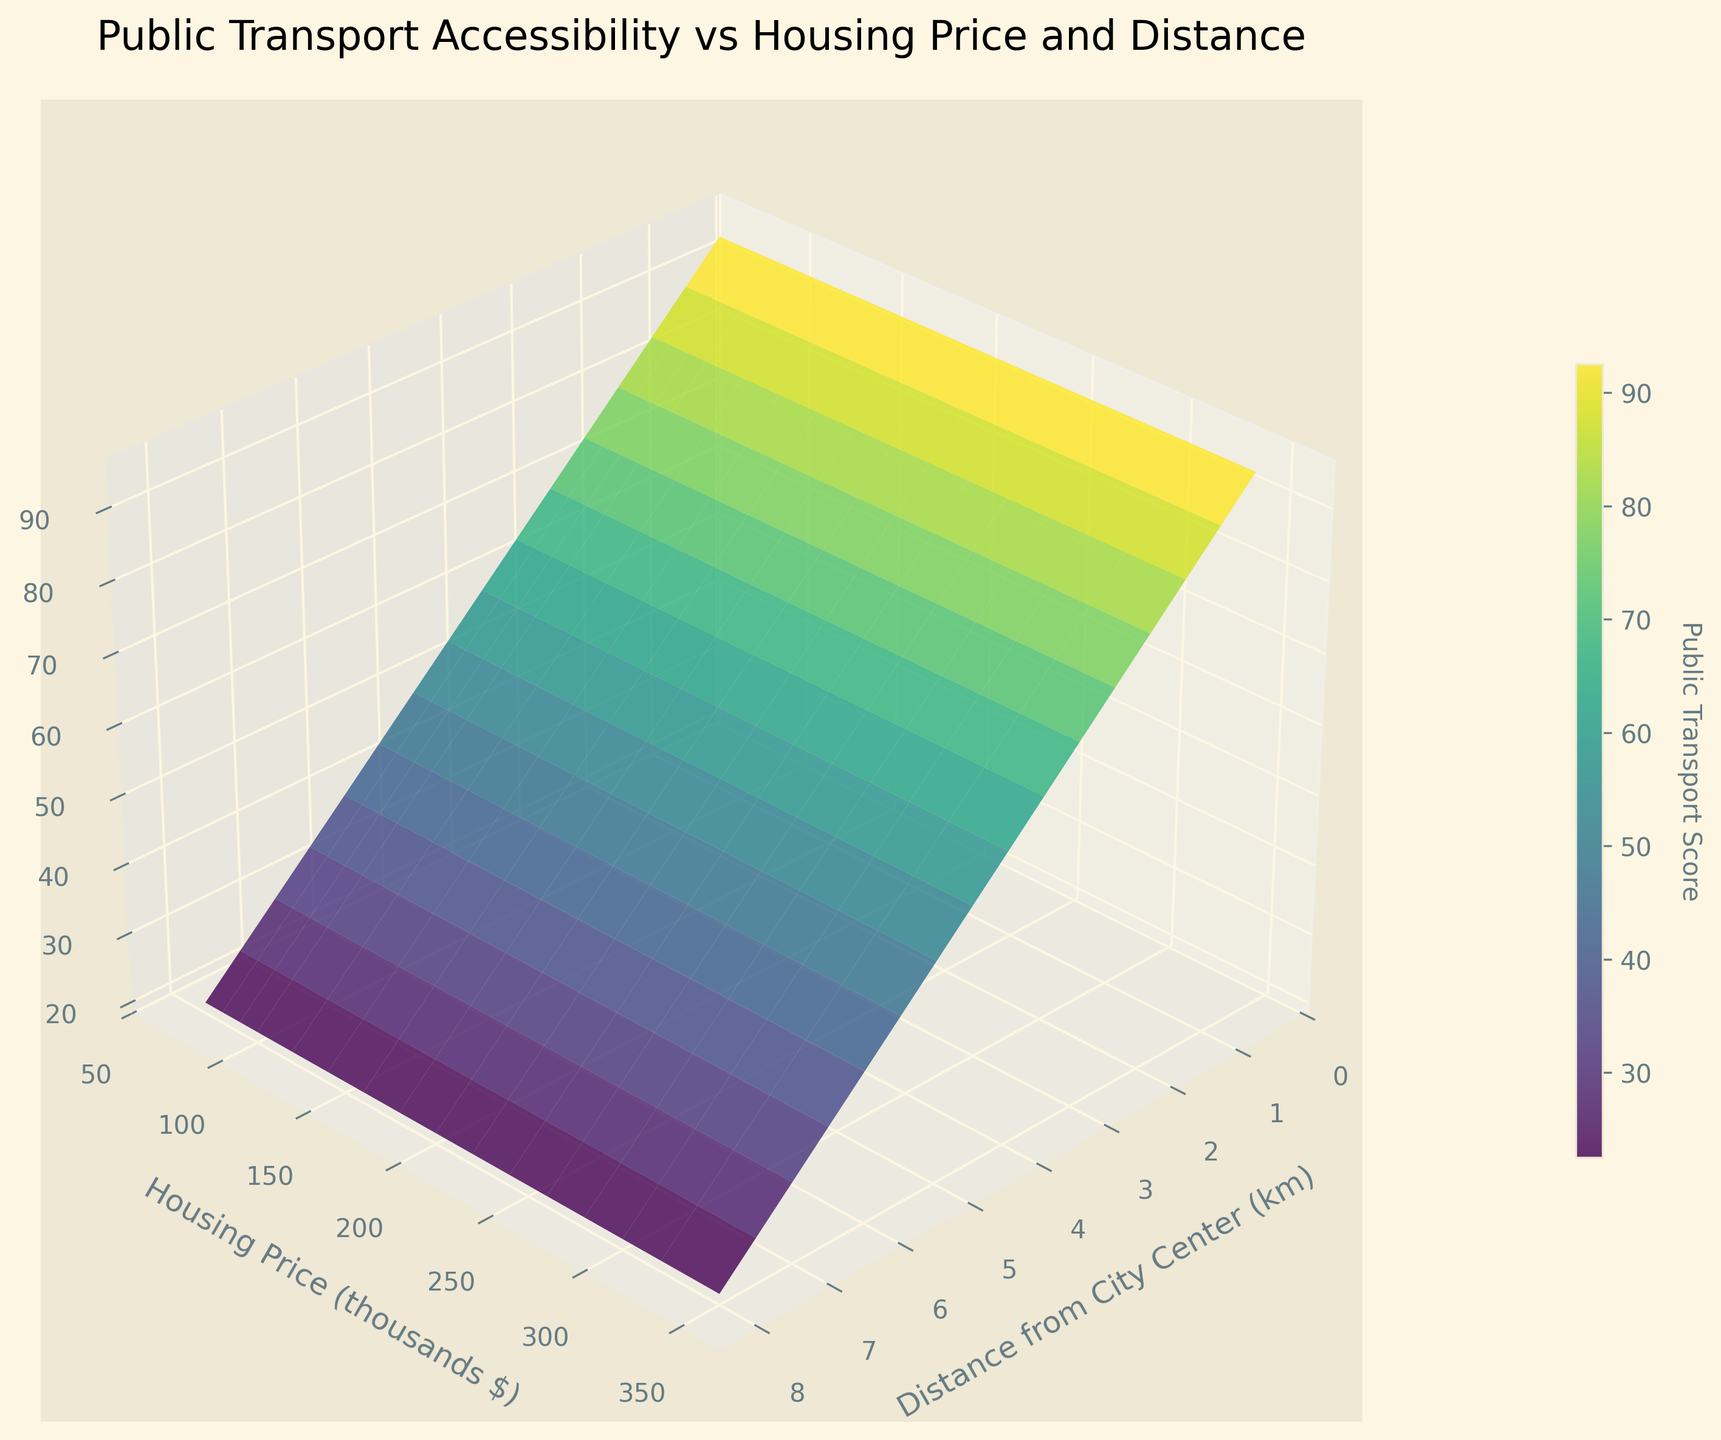What's the title of the plot? The title is usually located at the top of the plot, providing a brief description of what the plot represents.
Answer: Public Transport Accessibility vs Housing Price and Distance What does the color bar represent? The color bar is typically used to illustrate the range of values for a certain variable in the plot, as indicated by its label. Here, it indicates the range of Public Transport Scores.
Answer: Public Transport Score How does the Public Transport Score change with the distance from the city center? Observing the z-axis (Public Transport Score) as the x-axis (Distance from City Center) increases, the score consistently decreases, showing an inverse relationship.
Answer: It decreases At what distance from the city center does the Public Transport Score drop below 50? Refer to the point on the x-axis where the z-axis value (Public Transport Score) becomes less than 50.
Answer: 5 km Which housing price range has the highest Public Transport Score? By analyzing the y-axis (Housing Price) in conjunction with the color indicating Public Transport Score, the highest scores are seen at the lower end of the distance range.
Answer: $350,000 How does the public transport score vary with housing prices at a 3 km distance from the city center? At the 3 km mark on the x-axis, observe the corresponding scores on the z-axis across the range of housing prices; the score decreases as the housing prices decrease.
Answer: Decreases as housing prices decrease Compare public transport scores at 2 km and 7 km from the city center. Which one has a better score? By looking at the z-axis values at the points where the x-axis is 2 km and 7 km, it is clear that 2 km has a higher z-axis value.
Answer: 2 km What is the housing price when the Public Transport Score is 70? Find the z-axis value of 70 and trace it to the y-axis (Housing Price) for the corresponding house price.
Answer: $240,000 Which factor seems to have a more noticeable impact on the Public Transport Score: distance from the city center or housing price? By comparing the variations along the x-axis and y-axis and their influence on the z-axis values (Public Transport Score), distance from the city center shows a more pronounced variation as scores consistently decrease as distance increases.
Answer: Distance from the city center 